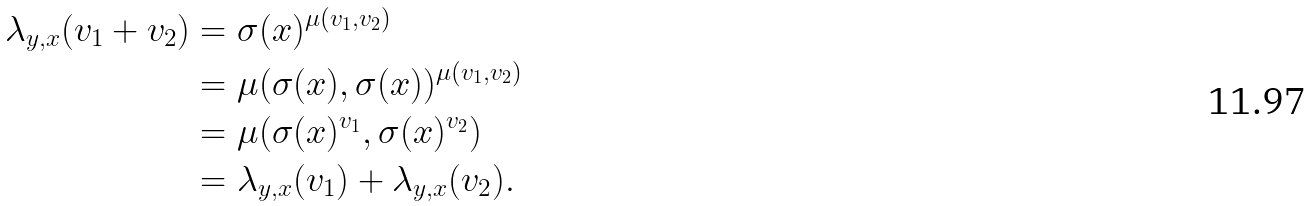<formula> <loc_0><loc_0><loc_500><loc_500>\lambda _ { y , x } ( v _ { 1 } + v _ { 2 } ) & = \sigma ( x ) ^ { \mu ( v _ { 1 } , v _ { 2 } ) } \\ & = \mu ( \sigma ( x ) , \sigma ( x ) ) ^ { \mu ( v _ { 1 } , v _ { 2 } ) } \\ & = \mu ( \sigma ( x ) ^ { v _ { 1 } } , \sigma ( x ) ^ { v _ { 2 } } ) \\ & = \lambda _ { y , x } ( v _ { 1 } ) + \lambda _ { y , x } ( v _ { 2 } ) .</formula> 